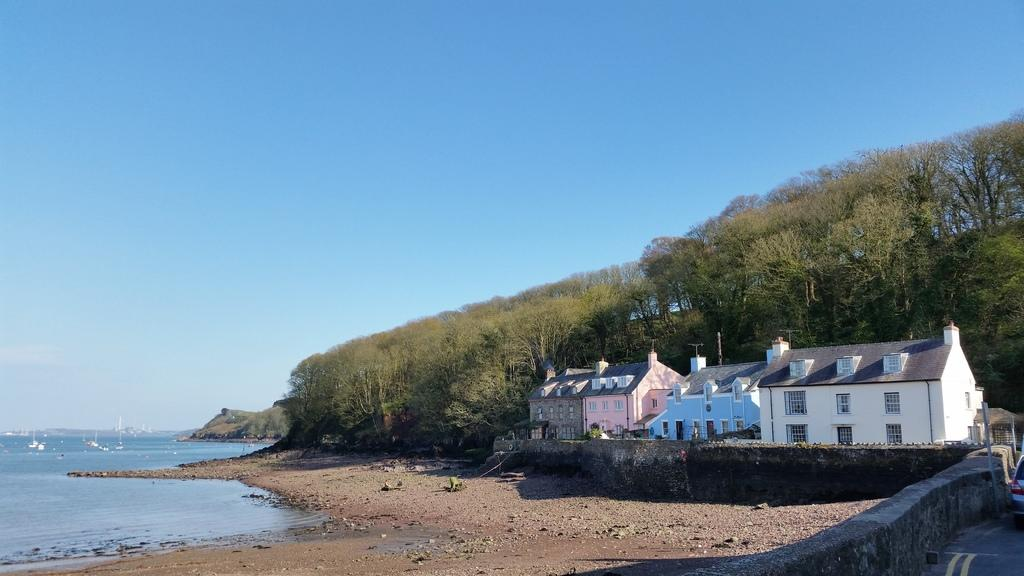What type of structures can be seen in the image? There are houses in the image. What feature is common to many of the houses in the image? There are windows in the image. What type of natural elements can be seen in the image? There are trees and water visible in the image. What mode of transportation can be seen on the road in the image? There is a vehicle on the road in the image. What is the color of the sky in the image? The sky is blue in the image. What type of coat is the judge wearing in the image? There is no judge or coat present in the image. What type of paper is being used to write on in the image? There is no paper or writing activity present in the image. 